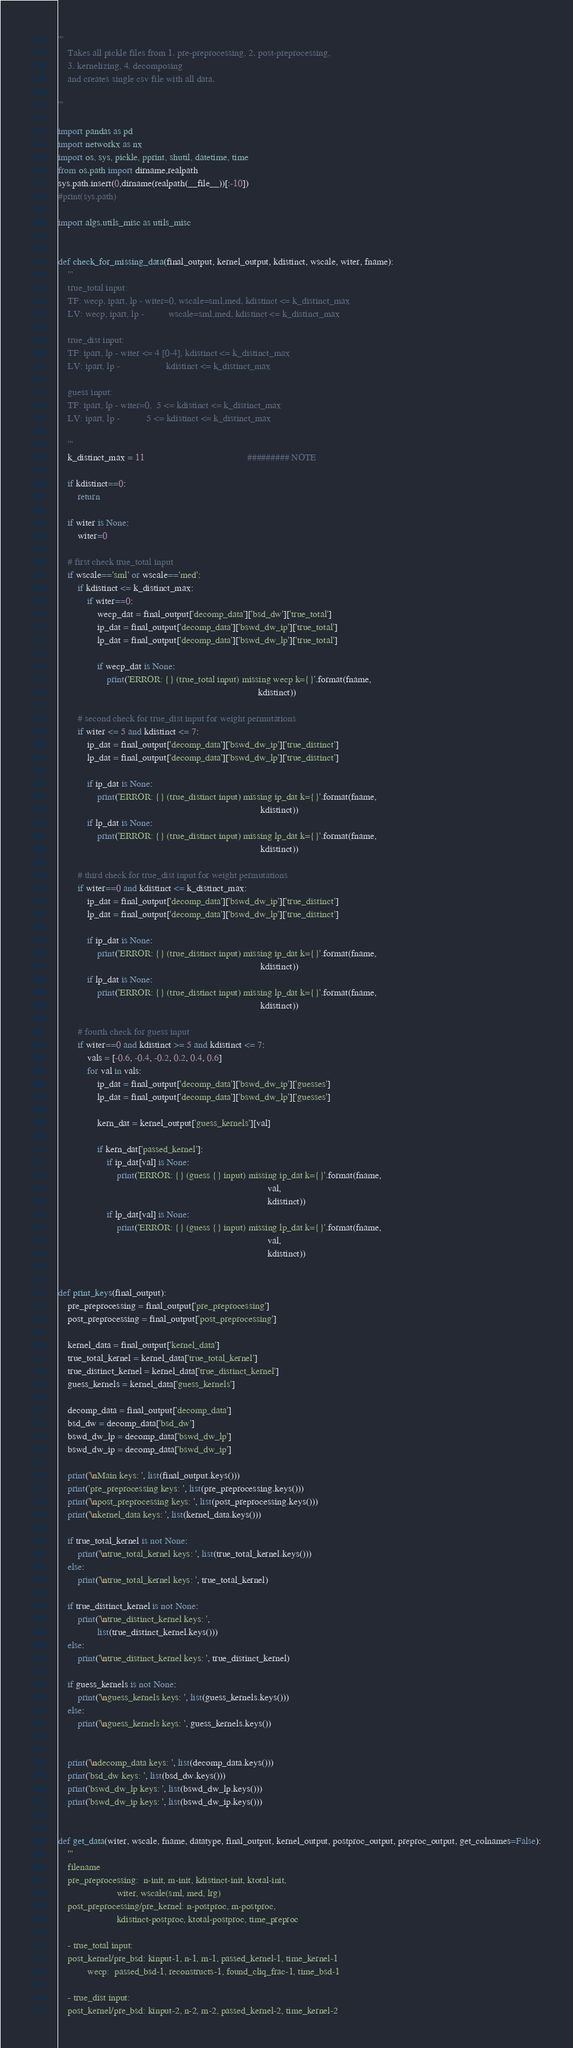Convert code to text. <code><loc_0><loc_0><loc_500><loc_500><_Python_>'''
    Takes all pickle files from 1. pre-preprocessing, 2. post-preprocessing, 
    3. kernelizing, 4. decomposing 
    and creates single csv file with all data. 

'''

import pandas as pd
import networkx as nx
import os, sys, pickle, pprint, shutil, datetime, time
from os.path import dirname,realpath
sys.path.insert(0,dirname(realpath(__file__))[:-10])
#print(sys.path)

import algs.utils_misc as utils_misc    


def check_for_missing_data(final_output, kernel_output, kdistinct, wscale, witer, fname):
    '''
    true_total input: 
    TF: wecp, ipart, lp - witer=0, wscale=sml,med, kdistinct <= k_distinct_max
    LV: wecp, ipart, lp -          wscale=sml,med, kdistinct <= k_distinct_max
    
    true_dist input:
    TF: ipart, lp - witer <= 4 [0-4], kdistinct <= k_distinct_max
    LV: ipart, lp -                   kdistinct <= k_distinct_max
    
    guess input:
    TF: ipart, lp - witer=0,  5 <= kdistinct <= k_distinct_max
    LV: ipart, lp -           5 <= kdistinct <= k_distinct_max
    
    '''
    k_distinct_max = 11                                          ######### NOTE
    
    if kdistinct==0:
        return
    
    if witer is None: 
        witer=0
                
    # first check true_total input
    if wscale=='sml' or wscale=='med':
        if kdistinct <= k_distinct_max:
            if witer==0:
                wecp_dat = final_output['decomp_data']['bsd_dw']['true_total']
                ip_dat = final_output['decomp_data']['bswd_dw_ip']['true_total']
                lp_dat = final_output['decomp_data']['bswd_dw_lp']['true_total']
                
                if wecp_dat is None:
                    print('ERROR: {} (true_total input) missing wecp k={}'.format(fname,
                                                                                  kdistinct))
        
        # second check for true_dist input for weight permutations
        if witer <= 5 and kdistinct <= 7:
            ip_dat = final_output['decomp_data']['bswd_dw_ip']['true_distinct']
            lp_dat = final_output['decomp_data']['bswd_dw_lp']['true_distinct']
            
            if ip_dat is None:
                print('ERROR: {} (true_distinct input) missing ip_dat k={}'.format(fname, 
                                                                                   kdistinct))
            if lp_dat is None:
                print('ERROR: {} (true_distinct input) missing lp_dat k={}'.format(fname,
                                                                                   kdistinct))
        
        # third check for true_dist input for weight permutations
        if witer==0 and kdistinct <= k_distinct_max:
            ip_dat = final_output['decomp_data']['bswd_dw_ip']['true_distinct']
            lp_dat = final_output['decomp_data']['bswd_dw_lp']['true_distinct']
            
            if ip_dat is None:
                print('ERROR: {} (true_distinct input) missing ip_dat k={}'.format(fname, 
                                                                                   kdistinct))
            if lp_dat is None:
                print('ERROR: {} (true_distinct input) missing lp_dat k={}'.format(fname,
                                                                                   kdistinct))
        
        # fourth check for guess input
        if witer==0 and kdistinct >= 5 and kdistinct <= 7:
            vals = [-0.6, -0.4, -0.2, 0.2, 0.4, 0.6]
            for val in vals:
                ip_dat = final_output['decomp_data']['bswd_dw_ip']['guesses']
                lp_dat = final_output['decomp_data']['bswd_dw_lp']['guesses']
                
                kern_dat = kernel_output['guess_kernels'][val]
                
                if kern_dat['passed_kernel']:
                    if ip_dat[val] is None:
                        print('ERROR: {} (guess {} input) missing ip_dat k={}'.format(fname, 
                                                                                      val,
                                                                                      kdistinct))
                    if lp_dat[val] is None:
                        print('ERROR: {} (guess {} input) missing lp_dat k={}'.format(fname, 
                                                                                      val,
                                                                                      kdistinct))
                

def print_keys(final_output):
    pre_preprocessing = final_output['pre_preprocessing']
    post_preprocessing = final_output['post_preprocessing']
    
    kernel_data = final_output['kernel_data']
    true_total_kernel = kernel_data['true_total_kernel']
    true_distinct_kernel = kernel_data['true_distinct_kernel']
    guess_kernels = kernel_data['guess_kernels']
    
    decomp_data = final_output['decomp_data']
    bsd_dw = decomp_data['bsd_dw']
    bswd_dw_lp = decomp_data['bswd_dw_lp']
    bswd_dw_ip = decomp_data['bswd_dw_ip']
        
    print('\nMain keys: ', list(final_output.keys()))
    print('pre_preprocessing keys: ', list(pre_preprocessing.keys()))
    print('\npost_preprocessing keys: ', list(post_preprocessing.keys()))
    print('\nkernel_data keys: ', list(kernel_data.keys()))
    
    if true_total_kernel is not None:
        print('\ntrue_total_kernel keys: ', list(true_total_kernel.keys()))
    else:
        print('\ntrue_total_kernel keys: ', true_total_kernel)
    
    if true_distinct_kernel is not None:
        print('\ntrue_distinct_kernel keys: ',
                list(true_distinct_kernel.keys()))
    else:
        print('\ntrue_distinct_kernel keys: ', true_distinct_kernel)
        
    if guess_kernels is not None:
        print('\nguess_kernels keys: ', list(guess_kernels.keys()))
    else:
        print('\nguess_kernels keys: ', guess_kernels.keys())
        
    
    print('\ndecomp_data keys: ', list(decomp_data.keys()))
    print('bsd_dw keys: ', list(bsd_dw.keys()))
    print('bswd_dw_lp keys: ', list(bswd_dw_lp.keys()))
    print('bswd_dw_ip keys: ', list(bswd_dw_ip.keys()))


def get_data(witer, wscale, fname, datatype, final_output, kernel_output, postproc_output, preproc_output, get_colnames=False):
    '''
    filename
    pre_preprocessing:  n-init, m-init, kdistinct-init, ktotal-init, 
                        witer, wscale(sml, med, lrg)
    post_preprocessing/pre_kernel: n-postproc, m-postproc, 
                        kdistinct-postproc, ktotal-postproc, time_preproc

    - true_total input: 
    post_kernel/pre_bsd: kinput-1, n-1, m-1, passed_kernel-1, time_kernel-1
            wecp:  passed_bsd-1, reconstructs-1, found_cliq_frac-1, time_bsd-1
    
    - true_dist input: 
    post_kernel/pre_bsd: kinput-2, n-2, m-2, passed_kernel-2, time_kernel-2</code> 